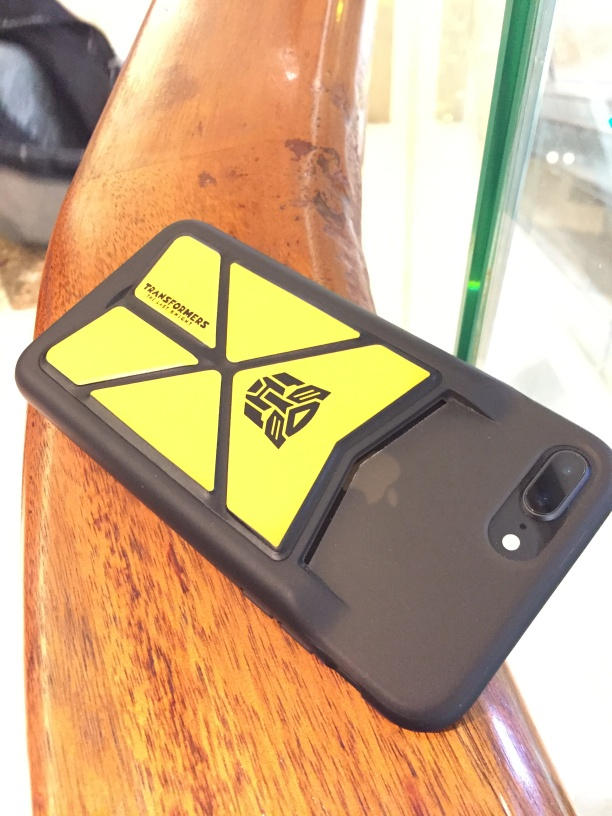Can you describe the aesthetic and design elements of the phone case? The phone case sports a striking contrast with its vivid yellow geometric pattern set against a black background. The angular, tessellated design of the emblem gives it a modern and dynamic appearance, potentially appealing to someone who enjoys bold and contemporary accessories. 